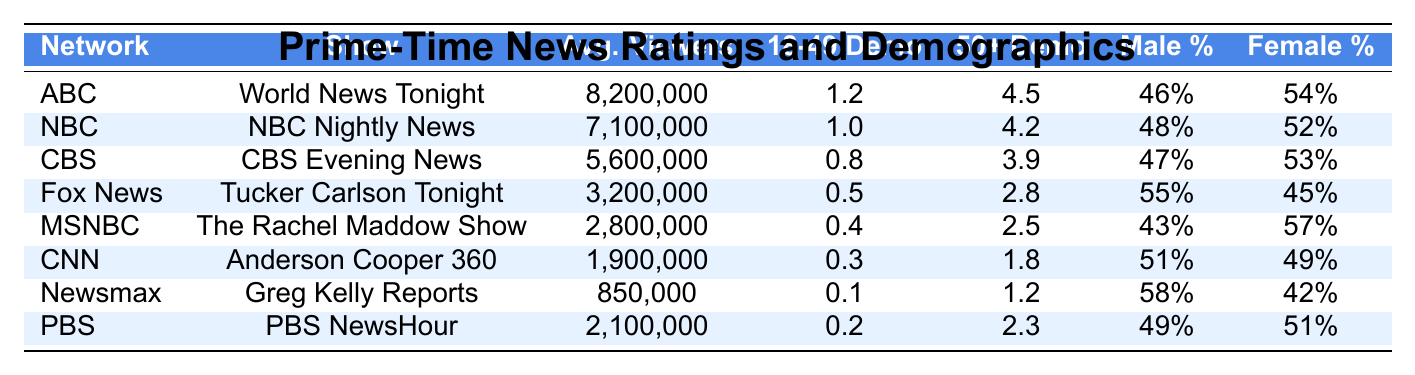What is the average viewership of 'World News Tonight'? The table shows the average viewers for 'World News Tonight' as 8,200,000.
Answer: 8,200,000 Which show has the highest 18-49 demographic rating? The highest 18-49 demographic rating in the table is for 'World News Tonight' with a rating of 1.2.
Answer: 1.2 What percentage of viewers for 'Tucker Carlson Tonight' are female? According to the table, 45% of viewers for 'Tucker Carlson Tonight' are female.
Answer: 45% How many average viewers does 'NBC Nightly News' have compared to 'CBS Evening News'? 'NBC Nightly News' has 7,100,000 viewers and 'CBS Evening News' has 5,600,000 viewers. The difference is 7,100,000 - 5,600,000 = 1,500,000.
Answer: 1,500,000 Which network's show has a lower average viewer count than 'PBS NewsHour'? 'Greg Kelly Reports' on Newsmax has 850,000 viewers, which is less than 'PBS NewsHour' which has 2,100,000.
Answer: Newsmax What is the combined average viewership of 'The Rachel Maddow Show' and 'Anderson Cooper 360'? The average viewership of 'The Rachel Maddow Show' is 2,800,000 and 'Anderson Cooper 360' is 1,900,000. Their combined average is 2,800,000 + 1,900,000 = 4,700,000.
Answer: 4,700,000 Is the percentage of male viewers higher for 'Fox News' than for 'CBS'? The table shows 55% male viewers for 'Fox News' and 47% for 'CBS', therefore, yes, 'Fox News' has a higher percentage of male viewers.
Answer: Yes Which show has the largest gap between male and female viewers? 'Greg Kelly Reports' has 58% male and 42% female viewers, resulting in a gap of 16%. Comparing gaps for other shows indicates no larger gaps exist.
Answer: Greg Kelly Reports What is the average demographic rating of 50+ for ABC and NBC combined? ABC has a 50+ demo of 4.5 and NBC has 4.2, the combined rating is (4.5 + 4.2) / 2 = 4.35.
Answer: 4.35 Are there more average viewers in total for networks with shows featuring 'NBC' and 'ABC' compared to 'CNN' and 'PBS'? Average viewers for 'NBC Nightly News' and 'World News Tonight' is 7,100,000 + 8,200,000 = 15,300,000; for 'CNN' and 'PBS', it's 1,900,000 + 2,100,000 = 4,000,000. Therefore, yes, 15,300,000 is greater than 4,000,000.
Answer: Yes What percentage of viewers for 'CBS Evening News' is aged 50 or older? 'CBS Evening News' has a 50+ demographic rating of 3.9 out of a total possible demographic rating, which cannot be expressed as a percentage without additional context; however, this rating indicates a significant older audience.
Answer: 3.9 